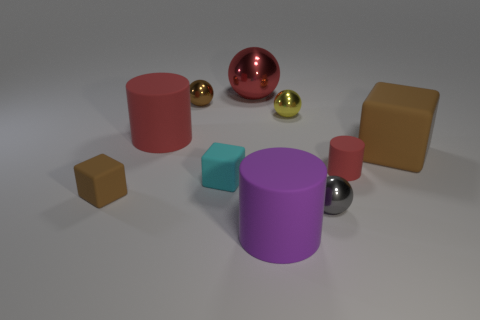Subtract all cylinders. How many objects are left? 7 Add 4 big brown things. How many big brown things exist? 5 Subtract 0 purple balls. How many objects are left? 10 Subtract all yellow matte balls. Subtract all gray balls. How many objects are left? 9 Add 9 big purple matte cylinders. How many big purple matte cylinders are left? 10 